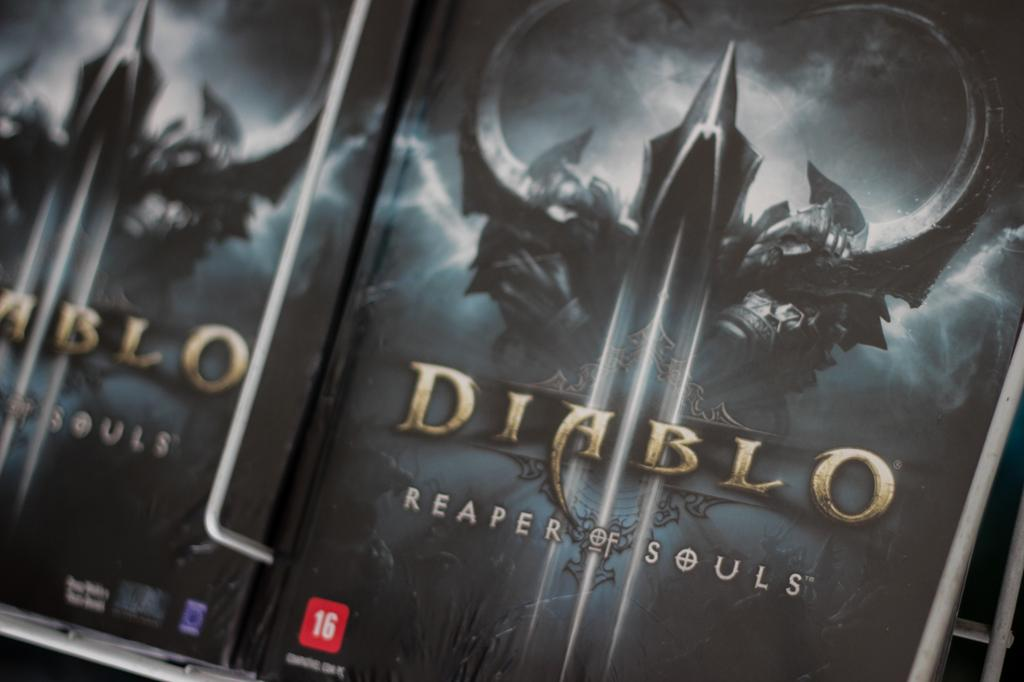What objects can be seen in the image? There are books in the image. Where are the books located? The books are in a shelf. What type of flag is visible in the image? There is no flag present in the image; it only features books in a shelf. 